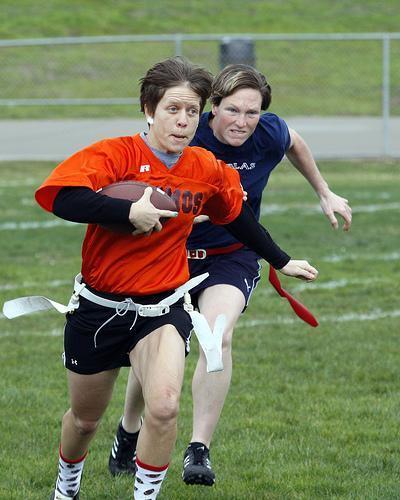How many people are in the photo?
Give a very brief answer. 2. 